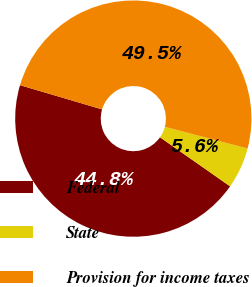<chart> <loc_0><loc_0><loc_500><loc_500><pie_chart><fcel>Federal<fcel>State<fcel>Provision for income taxes<nl><fcel>44.85%<fcel>5.64%<fcel>49.51%<nl></chart> 